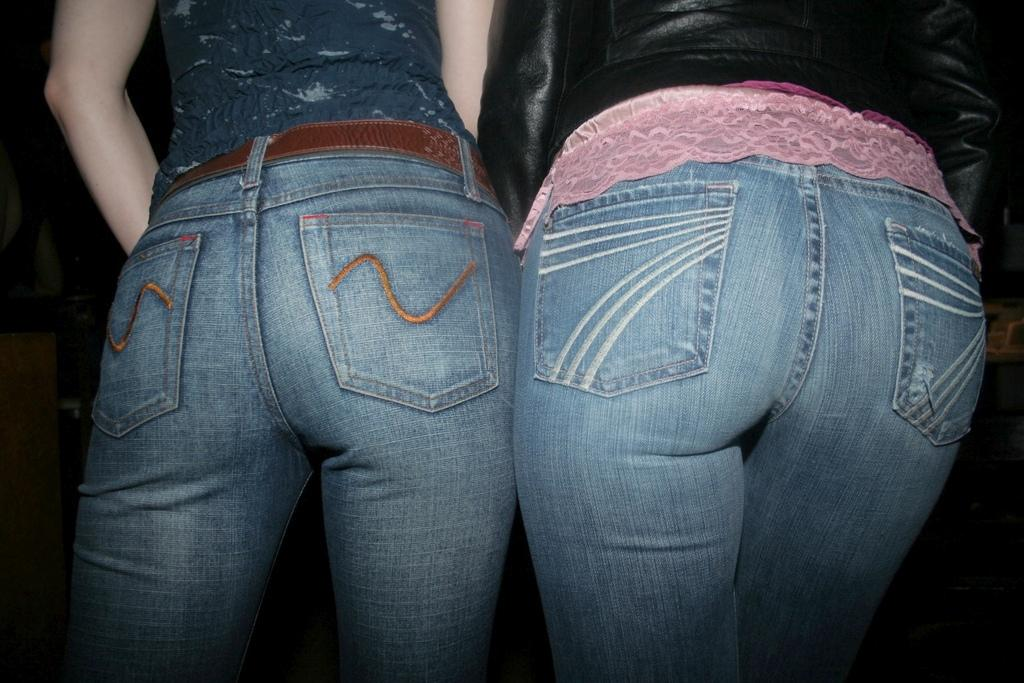How many people are in the image? There are two people standing in the image. What can be observed about the background of the image? The background of the image is dark. What type of error can be seen on the stove in the image? There is no stove present in the image, and therefore no error can be observed. 